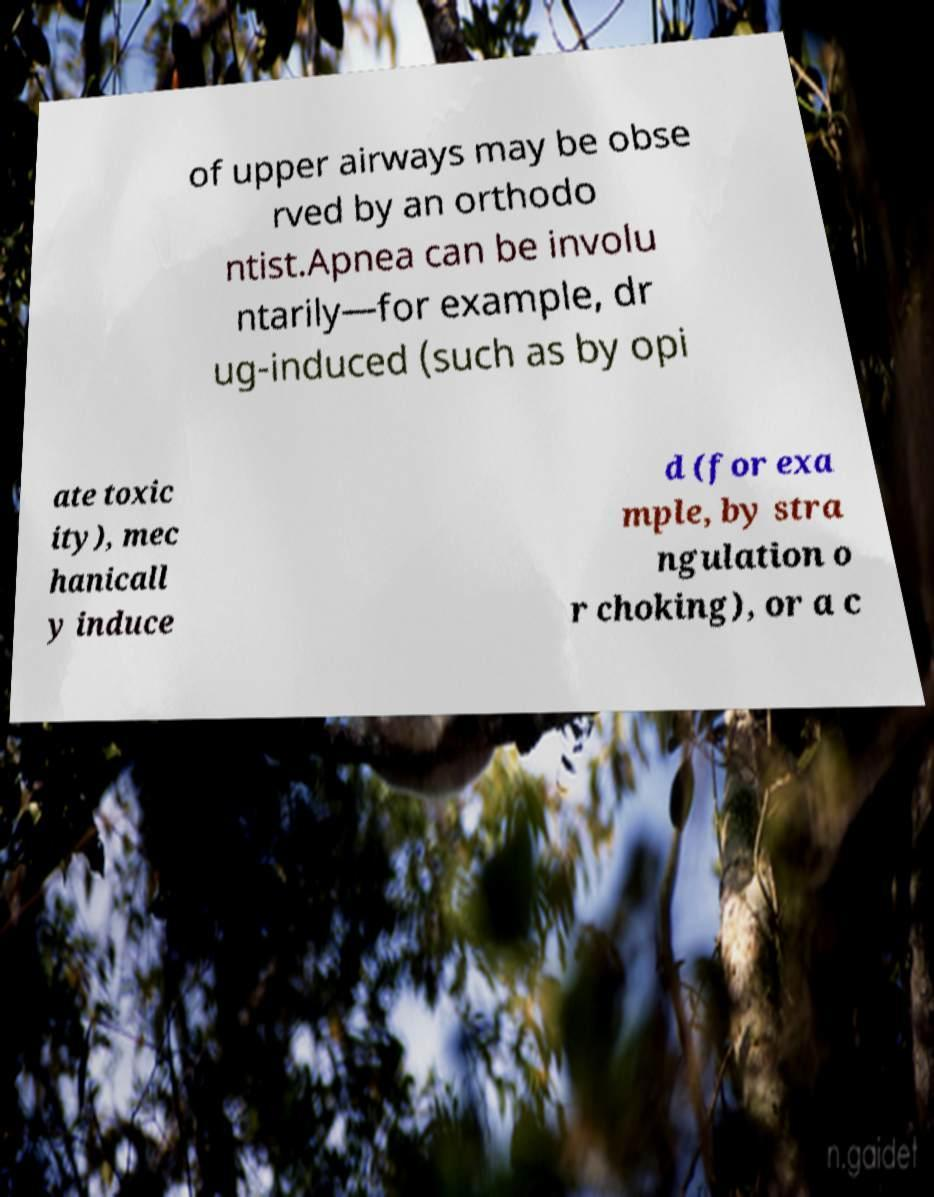Please read and relay the text visible in this image. What does it say? of upper airways may be obse rved by an orthodo ntist.Apnea can be involu ntarily—for example, dr ug-induced (such as by opi ate toxic ity), mec hanicall y induce d (for exa mple, by stra ngulation o r choking), or a c 